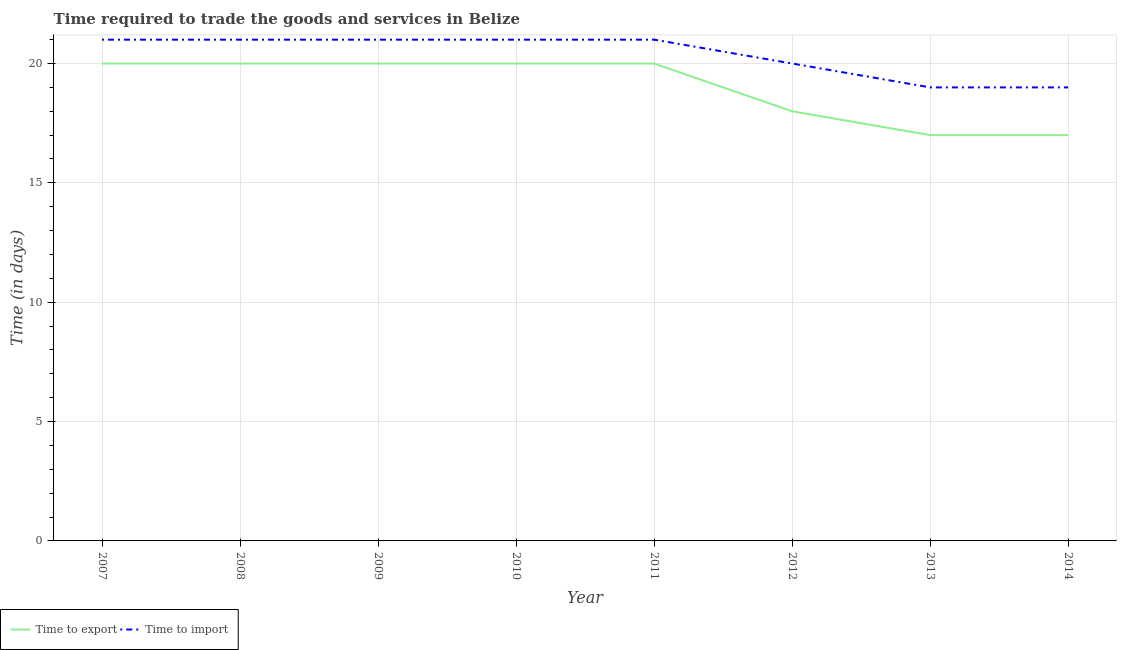How many different coloured lines are there?
Ensure brevity in your answer.  2. What is the time to export in 2012?
Offer a very short reply. 18. Across all years, what is the maximum time to export?
Offer a terse response. 20. Across all years, what is the minimum time to import?
Ensure brevity in your answer.  19. In which year was the time to export minimum?
Your response must be concise. 2013. What is the total time to export in the graph?
Ensure brevity in your answer.  152. What is the difference between the time to import in 2010 and the time to export in 2007?
Offer a very short reply. 1. What is the average time to import per year?
Ensure brevity in your answer.  20.38. In the year 2007, what is the difference between the time to export and time to import?
Ensure brevity in your answer.  -1. What is the ratio of the time to export in 2010 to that in 2014?
Offer a terse response. 1.18. What is the difference between the highest and the second highest time to import?
Offer a terse response. 0. What is the difference between the highest and the lowest time to export?
Offer a terse response. 3. Is the sum of the time to export in 2009 and 2013 greater than the maximum time to import across all years?
Your answer should be compact. Yes. Is the time to export strictly less than the time to import over the years?
Offer a very short reply. Yes. How many lines are there?
Provide a short and direct response. 2. Where does the legend appear in the graph?
Give a very brief answer. Bottom left. How many legend labels are there?
Your response must be concise. 2. What is the title of the graph?
Your answer should be very brief. Time required to trade the goods and services in Belize. What is the label or title of the Y-axis?
Keep it short and to the point. Time (in days). What is the Time (in days) in Time to export in 2008?
Give a very brief answer. 20. What is the Time (in days) in Time to import in 2008?
Your answer should be very brief. 21. What is the Time (in days) in Time to export in 2010?
Keep it short and to the point. 20. What is the Time (in days) of Time to export in 2011?
Give a very brief answer. 20. What is the Time (in days) in Time to export in 2012?
Your answer should be compact. 18. What is the Time (in days) of Time to import in 2012?
Your answer should be compact. 20. What is the Time (in days) of Time to import in 2013?
Your response must be concise. 19. What is the Time (in days) of Time to import in 2014?
Offer a terse response. 19. Across all years, what is the maximum Time (in days) of Time to export?
Your answer should be compact. 20. Across all years, what is the maximum Time (in days) in Time to import?
Offer a terse response. 21. Across all years, what is the minimum Time (in days) in Time to import?
Provide a succinct answer. 19. What is the total Time (in days) of Time to export in the graph?
Offer a very short reply. 152. What is the total Time (in days) of Time to import in the graph?
Make the answer very short. 163. What is the difference between the Time (in days) of Time to export in 2007 and that in 2008?
Make the answer very short. 0. What is the difference between the Time (in days) in Time to import in 2007 and that in 2008?
Your answer should be compact. 0. What is the difference between the Time (in days) in Time to export in 2007 and that in 2010?
Provide a succinct answer. 0. What is the difference between the Time (in days) of Time to import in 2007 and that in 2010?
Offer a very short reply. 0. What is the difference between the Time (in days) in Time to import in 2007 and that in 2011?
Offer a very short reply. 0. What is the difference between the Time (in days) of Time to export in 2007 and that in 2012?
Provide a succinct answer. 2. What is the difference between the Time (in days) of Time to import in 2007 and that in 2012?
Offer a terse response. 1. What is the difference between the Time (in days) in Time to import in 2008 and that in 2009?
Keep it short and to the point. 0. What is the difference between the Time (in days) in Time to import in 2008 and that in 2010?
Your answer should be very brief. 0. What is the difference between the Time (in days) in Time to export in 2008 and that in 2011?
Keep it short and to the point. 0. What is the difference between the Time (in days) in Time to import in 2008 and that in 2011?
Offer a very short reply. 0. What is the difference between the Time (in days) in Time to import in 2008 and that in 2012?
Keep it short and to the point. 1. What is the difference between the Time (in days) of Time to import in 2008 and that in 2013?
Your response must be concise. 2. What is the difference between the Time (in days) in Time to export in 2008 and that in 2014?
Offer a very short reply. 3. What is the difference between the Time (in days) of Time to import in 2008 and that in 2014?
Make the answer very short. 2. What is the difference between the Time (in days) of Time to import in 2009 and that in 2010?
Provide a succinct answer. 0. What is the difference between the Time (in days) of Time to import in 2009 and that in 2012?
Your response must be concise. 1. What is the difference between the Time (in days) in Time to export in 2009 and that in 2013?
Ensure brevity in your answer.  3. What is the difference between the Time (in days) in Time to import in 2009 and that in 2013?
Provide a short and direct response. 2. What is the difference between the Time (in days) in Time to export in 2009 and that in 2014?
Keep it short and to the point. 3. What is the difference between the Time (in days) in Time to import in 2009 and that in 2014?
Offer a terse response. 2. What is the difference between the Time (in days) of Time to export in 2010 and that in 2011?
Keep it short and to the point. 0. What is the difference between the Time (in days) in Time to import in 2010 and that in 2012?
Your response must be concise. 1. What is the difference between the Time (in days) of Time to import in 2010 and that in 2013?
Make the answer very short. 2. What is the difference between the Time (in days) of Time to export in 2010 and that in 2014?
Your answer should be very brief. 3. What is the difference between the Time (in days) in Time to export in 2011 and that in 2012?
Keep it short and to the point. 2. What is the difference between the Time (in days) in Time to import in 2011 and that in 2013?
Keep it short and to the point. 2. What is the difference between the Time (in days) of Time to export in 2012 and that in 2013?
Make the answer very short. 1. What is the difference between the Time (in days) of Time to import in 2013 and that in 2014?
Provide a succinct answer. 0. What is the difference between the Time (in days) in Time to export in 2007 and the Time (in days) in Time to import in 2008?
Keep it short and to the point. -1. What is the difference between the Time (in days) in Time to export in 2007 and the Time (in days) in Time to import in 2009?
Offer a very short reply. -1. What is the difference between the Time (in days) in Time to export in 2007 and the Time (in days) in Time to import in 2010?
Your answer should be compact. -1. What is the difference between the Time (in days) in Time to export in 2007 and the Time (in days) in Time to import in 2014?
Provide a short and direct response. 1. What is the difference between the Time (in days) in Time to export in 2008 and the Time (in days) in Time to import in 2010?
Keep it short and to the point. -1. What is the difference between the Time (in days) in Time to export in 2008 and the Time (in days) in Time to import in 2013?
Your answer should be very brief. 1. What is the difference between the Time (in days) in Time to export in 2009 and the Time (in days) in Time to import in 2010?
Provide a succinct answer. -1. What is the difference between the Time (in days) in Time to export in 2009 and the Time (in days) in Time to import in 2011?
Give a very brief answer. -1. What is the difference between the Time (in days) of Time to export in 2009 and the Time (in days) of Time to import in 2013?
Offer a very short reply. 1. What is the difference between the Time (in days) in Time to export in 2009 and the Time (in days) in Time to import in 2014?
Offer a terse response. 1. What is the difference between the Time (in days) in Time to export in 2010 and the Time (in days) in Time to import in 2013?
Provide a succinct answer. 1. What is the difference between the Time (in days) of Time to export in 2011 and the Time (in days) of Time to import in 2014?
Your answer should be very brief. 1. What is the difference between the Time (in days) of Time to export in 2012 and the Time (in days) of Time to import in 2014?
Offer a terse response. -1. What is the difference between the Time (in days) in Time to export in 2013 and the Time (in days) in Time to import in 2014?
Your answer should be compact. -2. What is the average Time (in days) of Time to export per year?
Your answer should be very brief. 19. What is the average Time (in days) in Time to import per year?
Provide a short and direct response. 20.38. In the year 2007, what is the difference between the Time (in days) of Time to export and Time (in days) of Time to import?
Provide a short and direct response. -1. In the year 2008, what is the difference between the Time (in days) in Time to export and Time (in days) in Time to import?
Provide a succinct answer. -1. In the year 2009, what is the difference between the Time (in days) in Time to export and Time (in days) in Time to import?
Make the answer very short. -1. What is the ratio of the Time (in days) of Time to export in 2007 to that in 2008?
Your answer should be compact. 1. What is the ratio of the Time (in days) of Time to import in 2007 to that in 2008?
Your answer should be very brief. 1. What is the ratio of the Time (in days) of Time to export in 2007 to that in 2009?
Provide a short and direct response. 1. What is the ratio of the Time (in days) of Time to import in 2007 to that in 2009?
Provide a short and direct response. 1. What is the ratio of the Time (in days) in Time to export in 2007 to that in 2013?
Provide a succinct answer. 1.18. What is the ratio of the Time (in days) of Time to import in 2007 to that in 2013?
Ensure brevity in your answer.  1.11. What is the ratio of the Time (in days) of Time to export in 2007 to that in 2014?
Ensure brevity in your answer.  1.18. What is the ratio of the Time (in days) in Time to import in 2007 to that in 2014?
Give a very brief answer. 1.11. What is the ratio of the Time (in days) of Time to export in 2008 to that in 2009?
Provide a short and direct response. 1. What is the ratio of the Time (in days) in Time to export in 2008 to that in 2010?
Your response must be concise. 1. What is the ratio of the Time (in days) of Time to export in 2008 to that in 2011?
Your response must be concise. 1. What is the ratio of the Time (in days) of Time to import in 2008 to that in 2012?
Offer a terse response. 1.05. What is the ratio of the Time (in days) in Time to export in 2008 to that in 2013?
Provide a succinct answer. 1.18. What is the ratio of the Time (in days) in Time to import in 2008 to that in 2013?
Give a very brief answer. 1.11. What is the ratio of the Time (in days) in Time to export in 2008 to that in 2014?
Ensure brevity in your answer.  1.18. What is the ratio of the Time (in days) of Time to import in 2008 to that in 2014?
Keep it short and to the point. 1.11. What is the ratio of the Time (in days) of Time to export in 2009 to that in 2011?
Your answer should be very brief. 1. What is the ratio of the Time (in days) of Time to import in 2009 to that in 2011?
Make the answer very short. 1. What is the ratio of the Time (in days) in Time to export in 2009 to that in 2013?
Provide a short and direct response. 1.18. What is the ratio of the Time (in days) in Time to import in 2009 to that in 2013?
Keep it short and to the point. 1.11. What is the ratio of the Time (in days) in Time to export in 2009 to that in 2014?
Your answer should be compact. 1.18. What is the ratio of the Time (in days) of Time to import in 2009 to that in 2014?
Keep it short and to the point. 1.11. What is the ratio of the Time (in days) in Time to export in 2010 to that in 2011?
Make the answer very short. 1. What is the ratio of the Time (in days) of Time to export in 2010 to that in 2012?
Provide a succinct answer. 1.11. What is the ratio of the Time (in days) in Time to export in 2010 to that in 2013?
Your answer should be very brief. 1.18. What is the ratio of the Time (in days) in Time to import in 2010 to that in 2013?
Your response must be concise. 1.11. What is the ratio of the Time (in days) of Time to export in 2010 to that in 2014?
Your answer should be very brief. 1.18. What is the ratio of the Time (in days) of Time to import in 2010 to that in 2014?
Offer a terse response. 1.11. What is the ratio of the Time (in days) of Time to import in 2011 to that in 2012?
Make the answer very short. 1.05. What is the ratio of the Time (in days) in Time to export in 2011 to that in 2013?
Offer a very short reply. 1.18. What is the ratio of the Time (in days) in Time to import in 2011 to that in 2013?
Provide a succinct answer. 1.11. What is the ratio of the Time (in days) of Time to export in 2011 to that in 2014?
Offer a very short reply. 1.18. What is the ratio of the Time (in days) of Time to import in 2011 to that in 2014?
Ensure brevity in your answer.  1.11. What is the ratio of the Time (in days) of Time to export in 2012 to that in 2013?
Your answer should be very brief. 1.06. What is the ratio of the Time (in days) in Time to import in 2012 to that in 2013?
Ensure brevity in your answer.  1.05. What is the ratio of the Time (in days) of Time to export in 2012 to that in 2014?
Ensure brevity in your answer.  1.06. What is the ratio of the Time (in days) of Time to import in 2012 to that in 2014?
Ensure brevity in your answer.  1.05. What is the ratio of the Time (in days) in Time to export in 2013 to that in 2014?
Your answer should be very brief. 1. What is the ratio of the Time (in days) in Time to import in 2013 to that in 2014?
Make the answer very short. 1. What is the difference between the highest and the second highest Time (in days) in Time to import?
Your answer should be very brief. 0. What is the difference between the highest and the lowest Time (in days) of Time to export?
Keep it short and to the point. 3. 